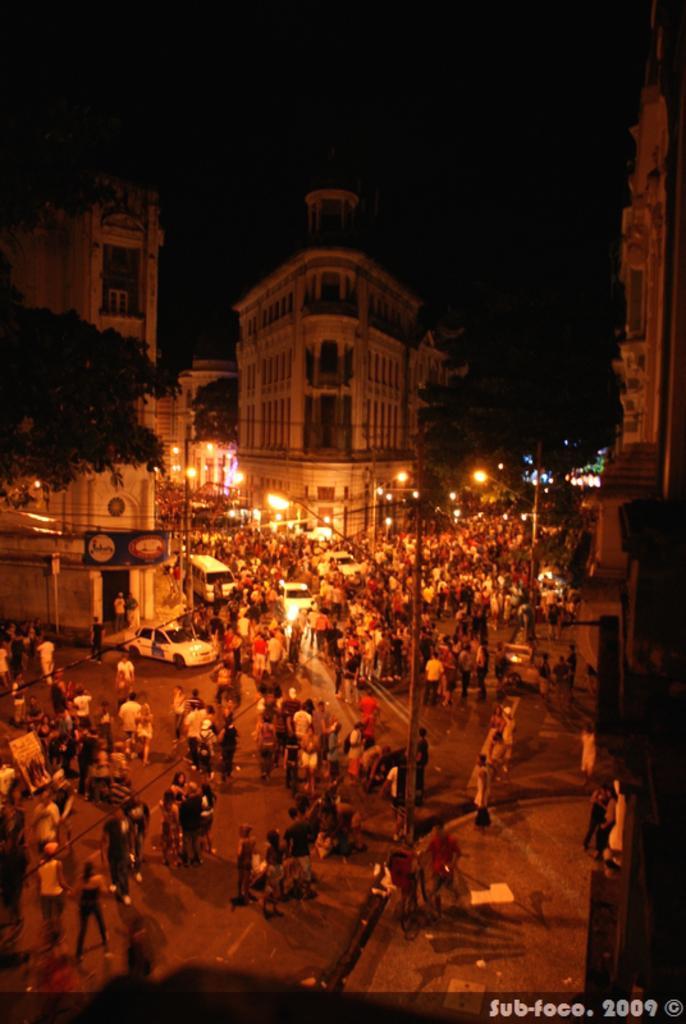Can you describe this image briefly? In this picture I can see the road in front, on which there are number of people, cars and few light poles. In the middle of this picture I can see the buildings and few trees. I see that it is totally dark in the background. On the bottom right corner of this picture I can see the watermark. 